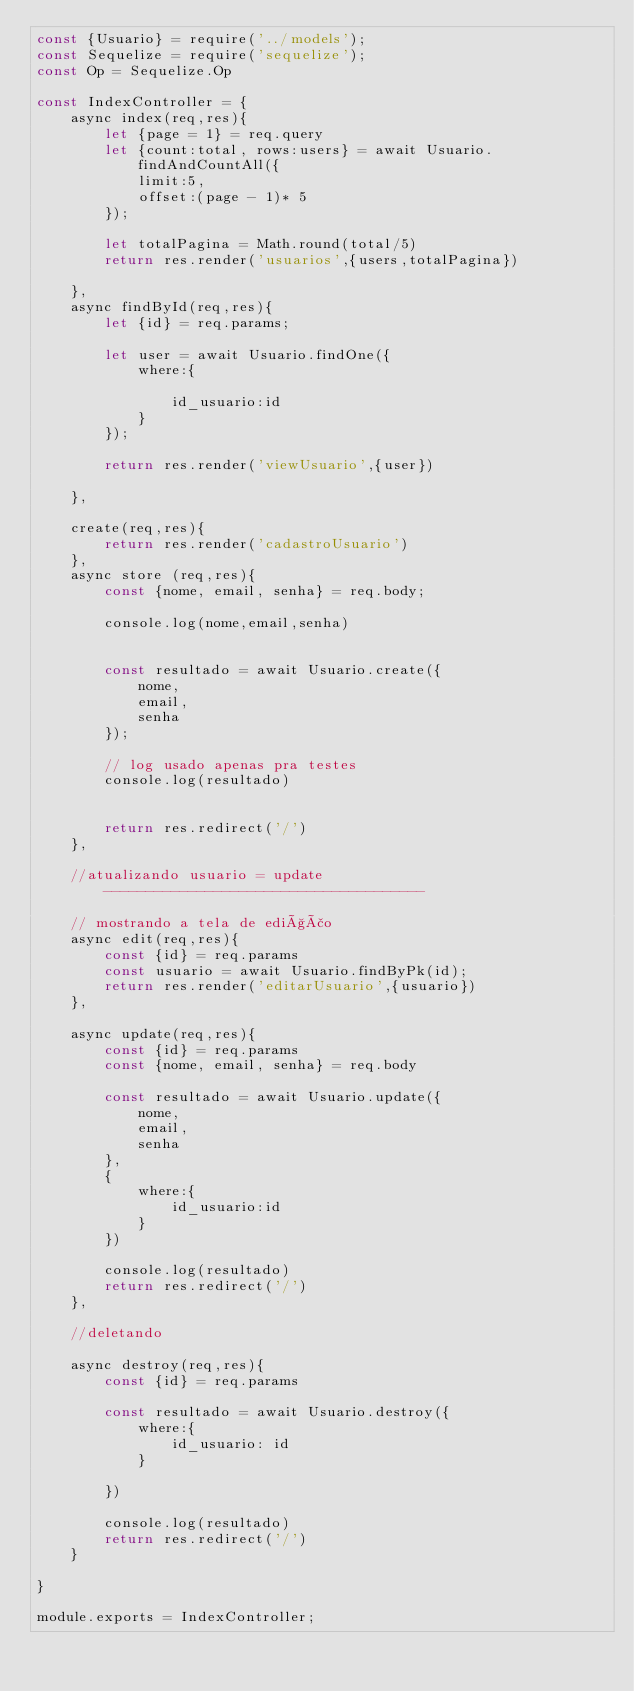<code> <loc_0><loc_0><loc_500><loc_500><_JavaScript_>const {Usuario} = require('../models');
const Sequelize = require('sequelize');
const Op = Sequelize.Op

const IndexController = {
    async index(req,res){
        let {page = 1} = req.query
        let {count:total, rows:users} = await Usuario.findAndCountAll({
            limit:5,
            offset:(page - 1)* 5
        });

        let totalPagina = Math.round(total/5)
        return res.render('usuarios',{users,totalPagina})

    },
    async findById(req,res){
        let {id} = req.params;

        let user = await Usuario.findOne({
            where:{

                id_usuario:id
            }
        });

        return res.render('viewUsuario',{user})

    },

    create(req,res){
        return res.render('cadastroUsuario')
    },
    async store (req,res){
        const {nome, email, senha} = req.body;

        console.log(nome,email,senha)

       
        const resultado = await Usuario.create({
            nome,
            email,
            senha
        });

        // log usado apenas pra testes
        console.log(resultado)


        return res.redirect('/')
    },

    //atualizando usuario = update--------------------------------------

    // mostrando a tela de edição
    async edit(req,res){
        const {id} = req.params
        const usuario = await Usuario.findByPk(id);
        return res.render('editarUsuario',{usuario})
    },

    async update(req,res){
        const {id} = req.params
        const {nome, email, senha} = req.body

        const resultado = await Usuario.update({
            nome,
            email,
            senha
        },
        {
            where:{
                id_usuario:id
            }
        })

        console.log(resultado)
        return res.redirect('/')
    },

    //deletando

    async destroy(req,res){
        const {id} = req.params

        const resultado = await Usuario.destroy({
            where:{
                id_usuario: id
            }

        })

        console.log(resultado)
        return res.redirect('/')
    }

}

module.exports = IndexController;</code> 